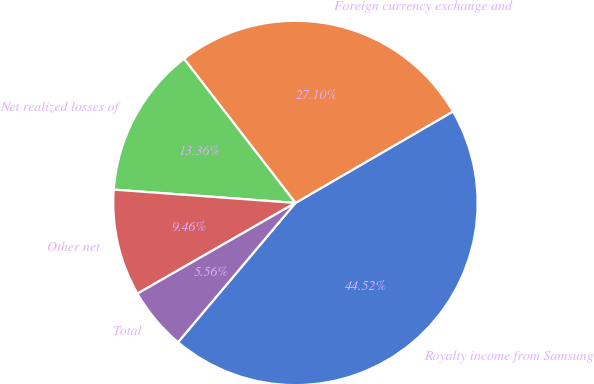Convert chart to OTSL. <chart><loc_0><loc_0><loc_500><loc_500><pie_chart><fcel>Royalty income from Samsung<fcel>Foreign currency exchange and<fcel>Net realized losses of<fcel>Other net<fcel>Total<nl><fcel>44.52%<fcel>27.1%<fcel>13.36%<fcel>9.46%<fcel>5.56%<nl></chart> 